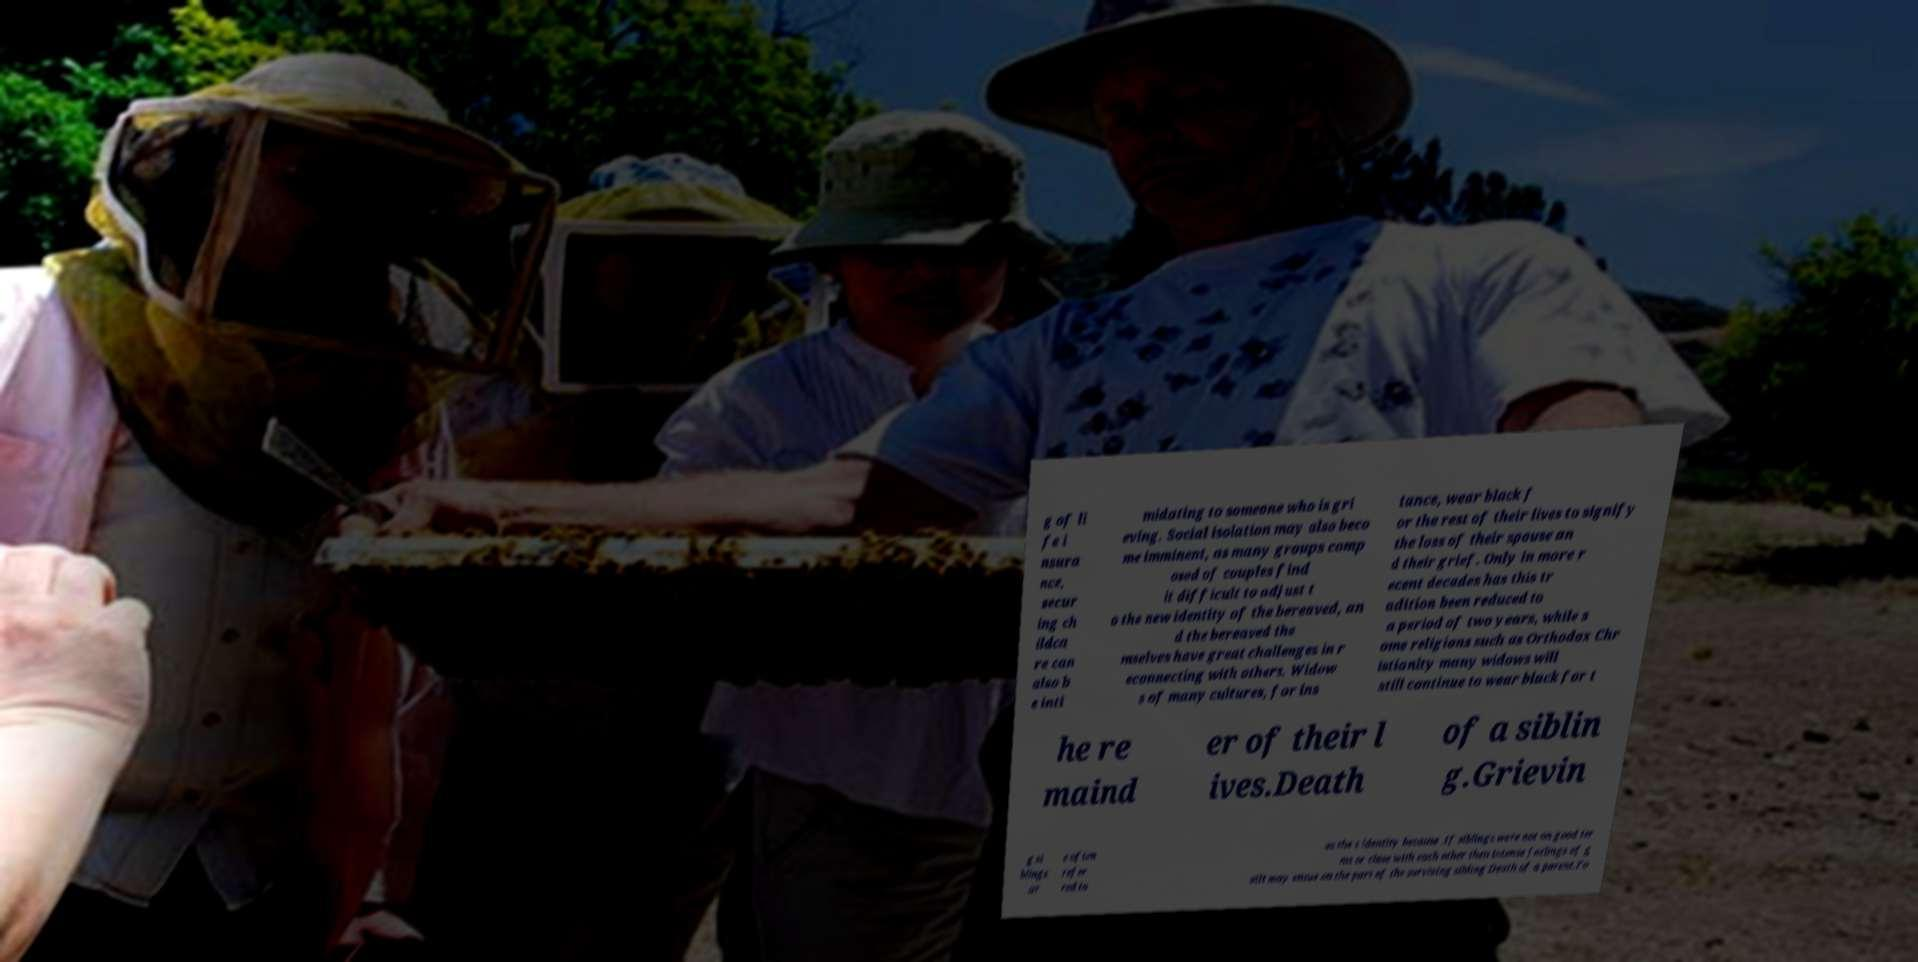Please identify and transcribe the text found in this image. g of li fe i nsura nce, secur ing ch ildca re can also b e inti midating to someone who is gri eving. Social isolation may also beco me imminent, as many groups comp osed of couples find it difficult to adjust t o the new identity of the bereaved, an d the bereaved the mselves have great challenges in r econnecting with others. Widow s of many cultures, for ins tance, wear black f or the rest of their lives to signify the loss of their spouse an d their grief. Only in more r ecent decades has this tr adition been reduced to a period of two years, while s ome religions such as Orthodox Chr istianity many widows will still continue to wear black for t he re maind er of their l ives.Death of a siblin g.Grievin g si blings ar e often refer red to as the s identity because .If siblings were not on good ter ms or close with each other then intense feelings of g uilt may ensue on the part of the surviving sibling Death of a parent.Fo 